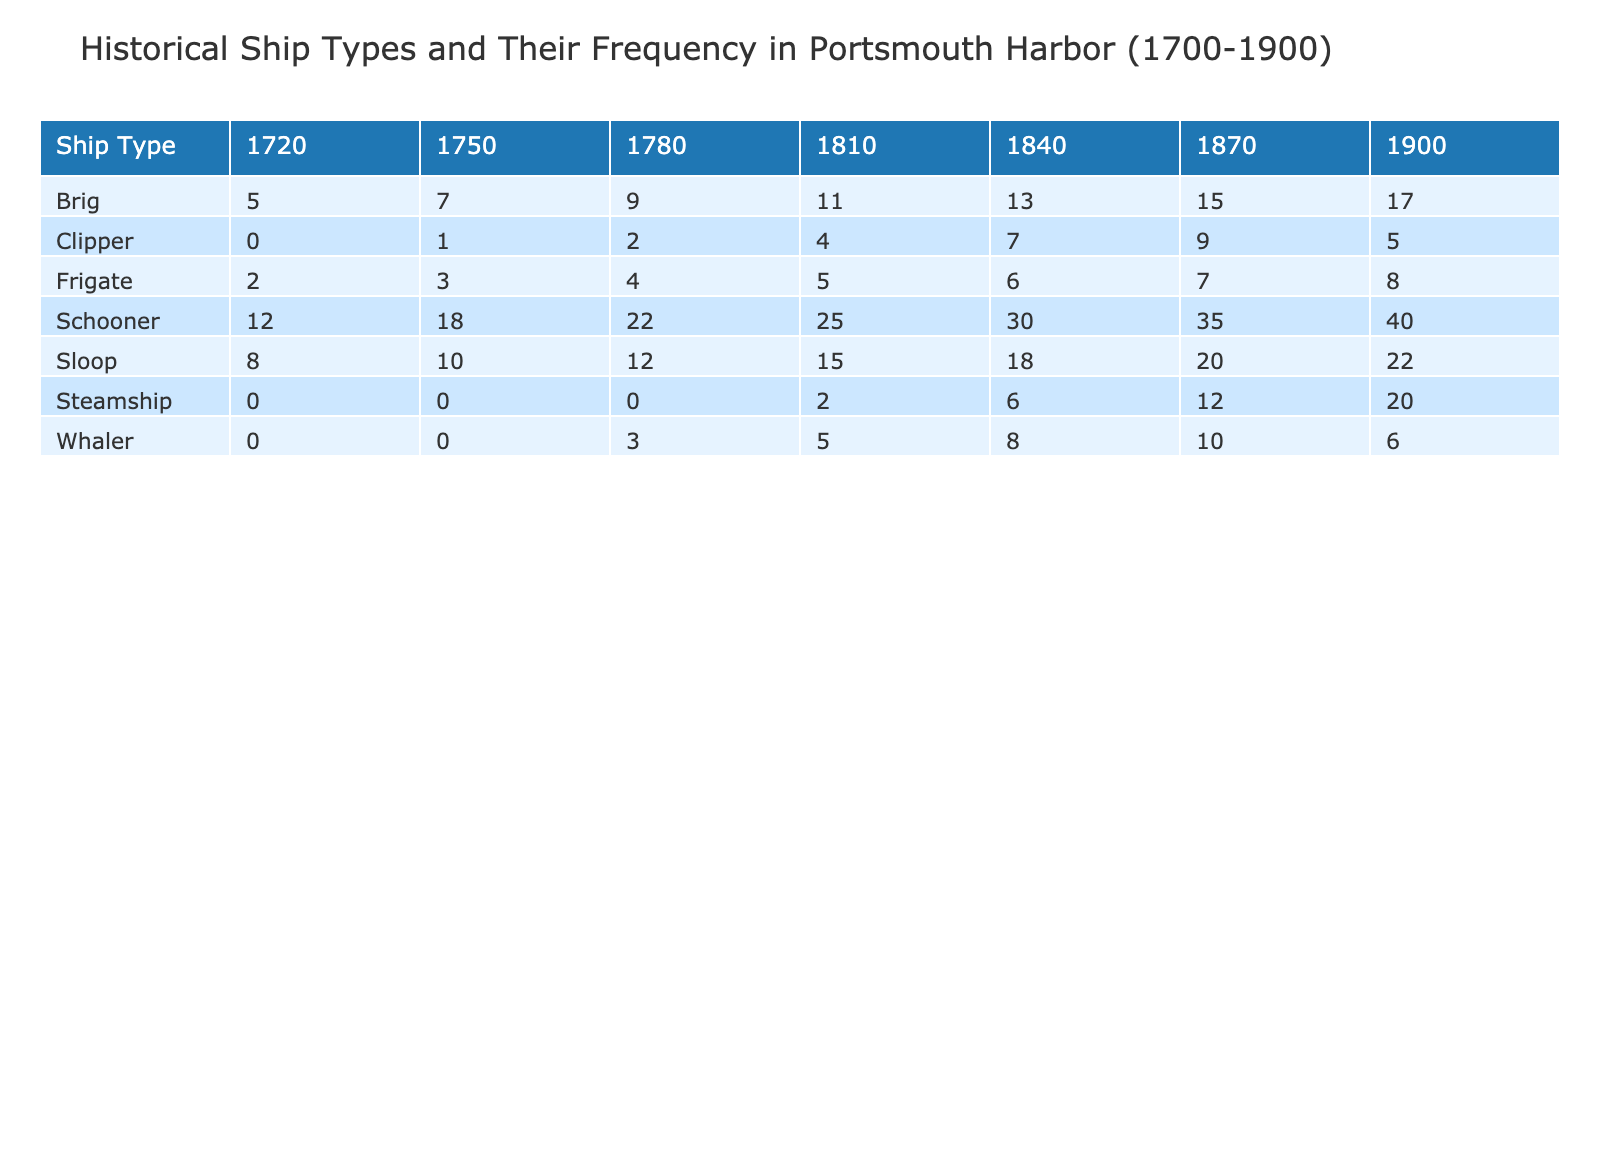What is the frequency of Schooners in 1840? By looking at the row for Schooners and the column for the year 1840, we see the value listed as 30.
Answer: 30 How many Sloops were recorded in the year 1810? Referring to the Sloop row and checking the column for 1810, the frequency recorded is 15.
Answer: 15 Which ship type had the highest frequency in 1900? In the year 1900, we compare the frequencies of all ship types. The highest frequency is found in the Schooner with a frequency of 40.
Answer: 40 What is the total frequency of all Brig ships from 1700 to 1900? To find this total, we sum the frequencies of Brig ships across all listed years: 5 (1720) + 7 (1750) + 9 (1780) + 11 (1810) + 13 (1840) + 15 (1870) + 17 (1900) = 77.
Answer: 77 Is there a Steamship recorded in the year 1750? Checking the Steamship row, we notice there is no entry for the year 1750. Therefore, the answer is no.
Answer: No What is the difference in frequencies between Schooners in 1870 and 1840? First, we have the frequency for Schooners in 1870, which is 35, and for 1840, it is 30. The difference is calculated as 35 - 30 = 5.
Answer: 5 Which ship type had the lowest frequency in 1780? We review the frequencies of all ship types in 1780. The Clipper had the lowest frequency with 2.
Answer: 2 What was the total frequency of Whalers across all years? Summing the frequencies of Whalers gives us: 3 (1780) + 5 (1810) + 8 (1840) + 10 (1870) + 6 (1900) = 32.
Answer: 32 Was the Frigate ship type more common than the Clipper in 1810? We compare the frequencies: Frigate had a frequency of 5 while the Clipper had a frequency of 4. Therefore, yes, the Frigate was more common.
Answer: Yes 